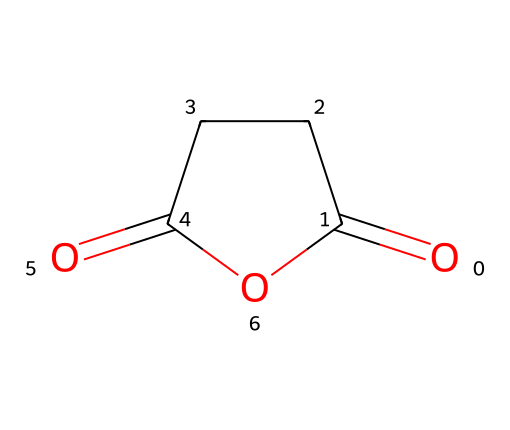What is the molecular formula of succinic anhydride? To determine the molecular formula from the SMILES representation, you can interpret the structure to identify the types and counts of atoms it contains. In the given structure, there are 4 carbons (C), 4 oxygens (O), and 6 hydrogens (H). Thus, the molecular formula is C4H4O3.
Answer: C4H4O3 How many carbon atoms are in succinic anhydride? By analyzing the SMILES representation, count the number of carbon atoms present in the structure. There are 4 carbon atoms connected in a ring structure.
Answer: 4 What type of functional groups are present in succinic anhydride? In the structure, look for recognizable functional groups. The SMILES shows an anhydride with both carbonyl (C=O) and cyclic components. The key functional group present is an anhydride functional group, characterized by the presence of two carbonyl groups connected through an oxygen atom.
Answer: anhydride What is the total number of atoms in succinic anhydride? To find the total number of atoms, add the count of each type of atom as identified. There are 4 carbons, 4 hydrogens, and 3 oxygens, leading to a total of 11 atoms.
Answer: 11 How many oxygen atoms are part of the anhydride functional group in succinic anhydride? Examine the structure to identify the oxygen atoms that are part of the anhydride functional group. There are 3 oxygen atoms, including one that is bridging between the two carbonyl groups.
Answer: 3 What is the relationship between succinic anhydride and succinic acid? Recognize that succinic anhydride is derived from succinic acid through the loss of water (dehydration). Therefore, they are directly related, with succinic anhydride representing the anhydrous form of succinic acid.
Answer: dehydration Is succinic anhydride considered eco-friendly? In the context of eco-friendly materials, succinic anhydride can be considered more sustainable since it is derived from renewable sources. The use of it in producing biodegradable plastics supports eco-friendly practices.
Answer: yes 